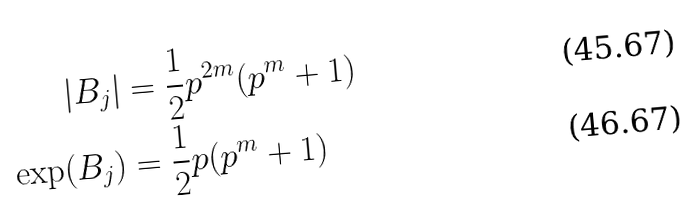Convert formula to latex. <formula><loc_0><loc_0><loc_500><loc_500>\left | B _ { j } \right | & = \frac { 1 } { 2 } p ^ { 2 m } ( p ^ { m } + 1 ) \\ \exp ( B _ { j } ) & = \frac { 1 } { 2 } p ( p ^ { m } + 1 )</formula> 